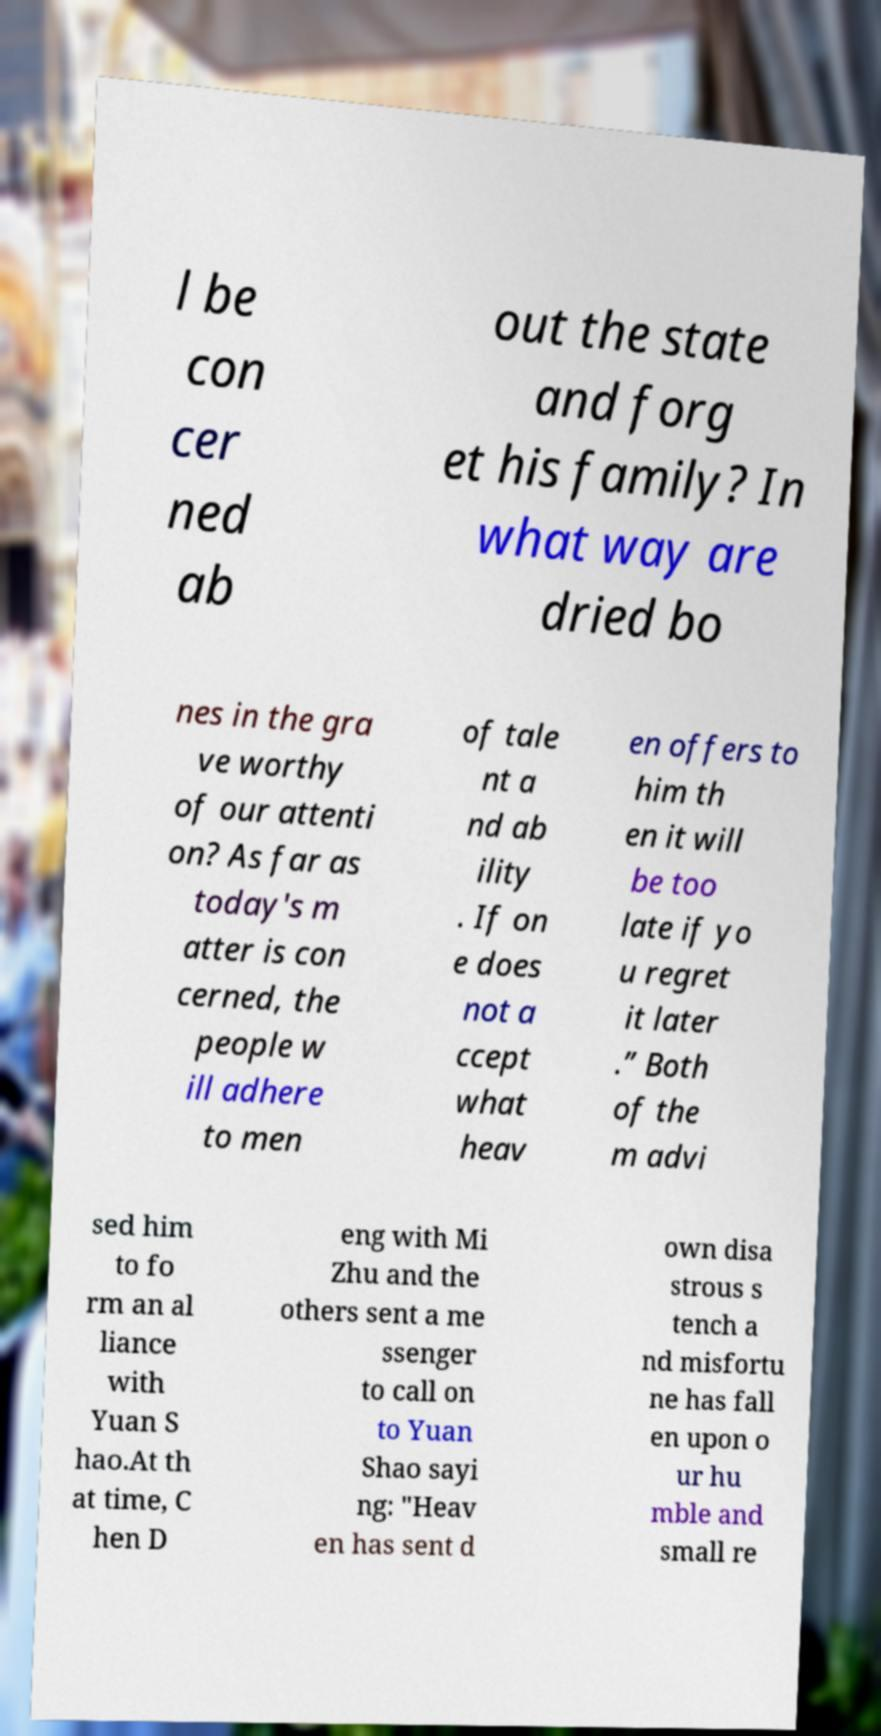Can you accurately transcribe the text from the provided image for me? l be con cer ned ab out the state and forg et his family? In what way are dried bo nes in the gra ve worthy of our attenti on? As far as today's m atter is con cerned, the people w ill adhere to men of tale nt a nd ab ility . If on e does not a ccept what heav en offers to him th en it will be too late if yo u regret it later .” Both of the m advi sed him to fo rm an al liance with Yuan S hao.At th at time, C hen D eng with Mi Zhu and the others sent a me ssenger to call on to Yuan Shao sayi ng: "Heav en has sent d own disa strous s tench a nd misfortu ne has fall en upon o ur hu mble and small re 